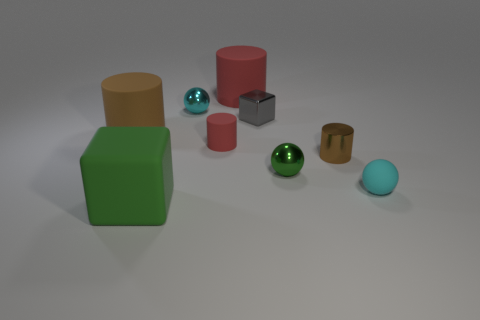There is a green block that is the same material as the large brown object; what is its size?
Offer a terse response. Large. There is a rubber object that is to the left of the green cube; is its size the same as the brown cylinder that is to the right of the big brown thing?
Offer a very short reply. No. There is a red cylinder that is the same size as the matte cube; what material is it?
Provide a succinct answer. Rubber. What is the material of the tiny object that is both behind the big brown cylinder and on the left side of the small gray shiny object?
Your answer should be compact. Metal. Is there a large green matte cylinder?
Your answer should be compact. No. Does the tiny cube have the same color as the big object in front of the small red rubber thing?
Keep it short and to the point. No. There is another small ball that is the same color as the tiny matte ball; what is it made of?
Your answer should be compact. Metal. Is there anything else that is the same shape as the small gray metallic object?
Provide a short and direct response. Yes. What is the shape of the red matte object that is behind the big rubber cylinder to the left of the matte object that is behind the tiny cyan metal ball?
Offer a terse response. Cylinder. What shape is the tiny red thing?
Provide a short and direct response. Cylinder. 